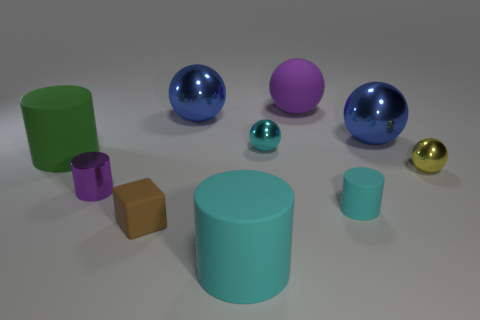Subtract all purple spheres. How many spheres are left? 4 Subtract 3 balls. How many balls are left? 2 Subtract all yellow cylinders. How many blue spheres are left? 2 Subtract all purple cylinders. How many cylinders are left? 3 Subtract all cylinders. How many objects are left? 6 Subtract all blue balls. Subtract all cyan cylinders. How many balls are left? 3 Add 8 purple metallic cylinders. How many purple metallic cylinders are left? 9 Add 10 metallic blocks. How many metallic blocks exist? 10 Subtract 0 red cylinders. How many objects are left? 10 Subtract all metal balls. Subtract all yellow balls. How many objects are left? 5 